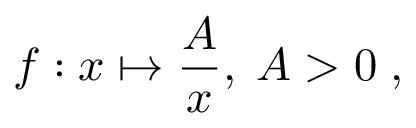Convert formula to latex. <formula><loc_0><loc_0><loc_500><loc_500>f \colon x \mapsto { \frac { A } { x } } , \, A > 0 \, ,</formula> 